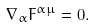Convert formula to latex. <formula><loc_0><loc_0><loc_500><loc_500>\nabla _ { \alpha } { F } ^ { \alpha \mu } = 0 .</formula> 